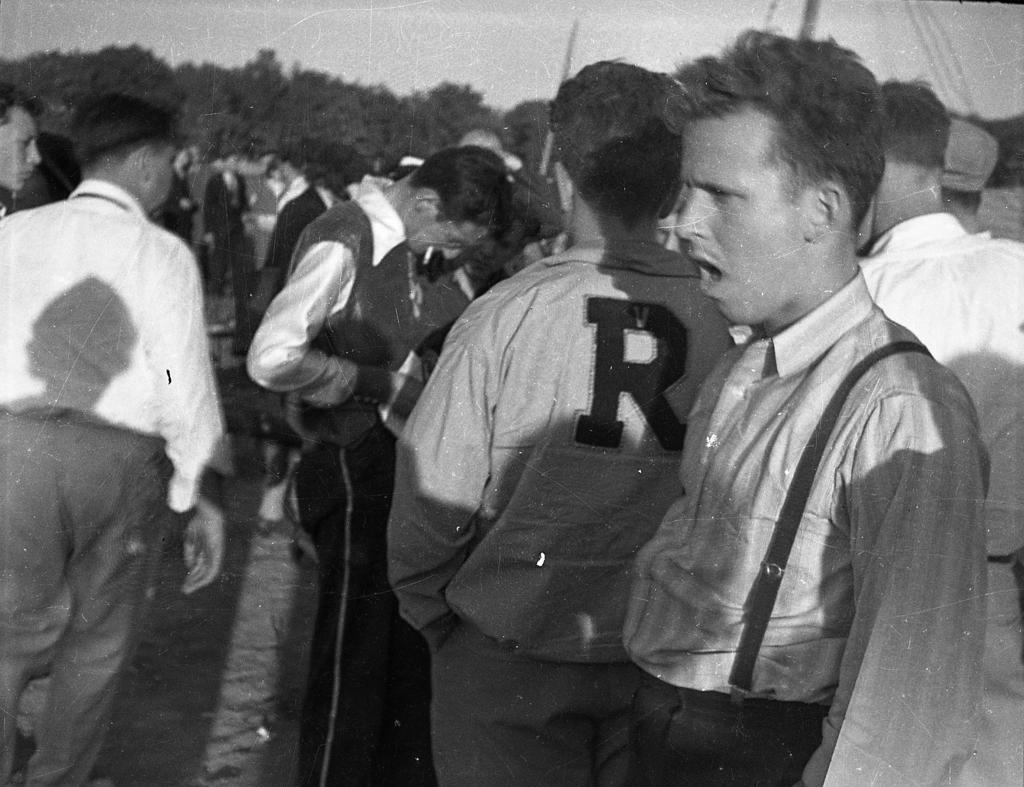In one or two sentences, can you explain what this image depicts? This is a black and white image and here we can see many people standing and in the background, there are trees and we can see some sticks. 